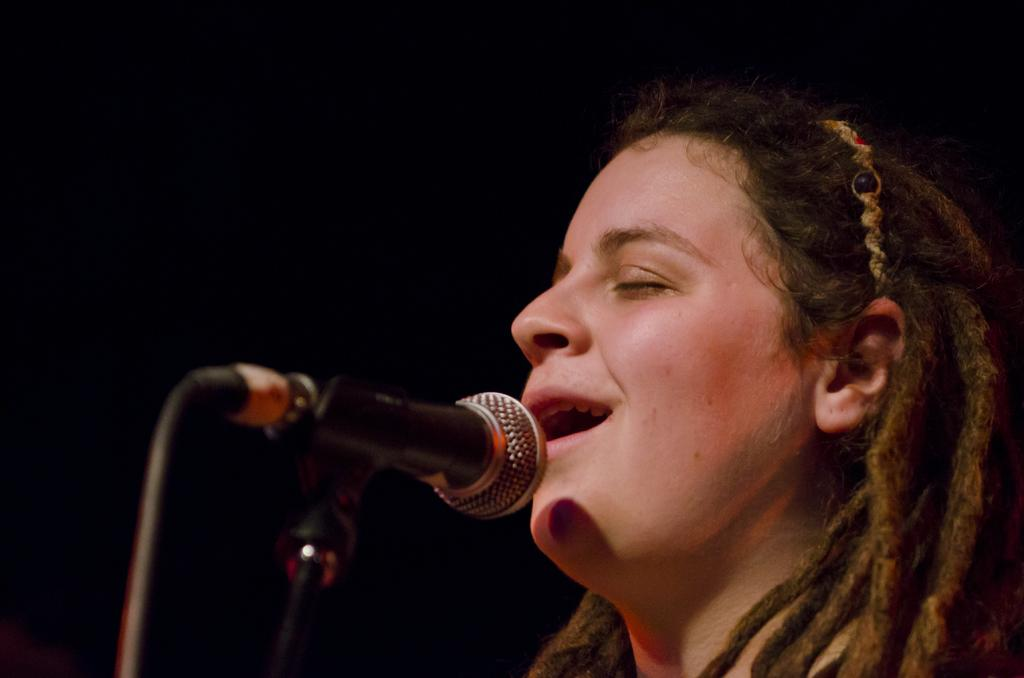What is happening in the image? There is a person in the image who is singing a song. What object is in front of the person? There is a microphone (mike) in front of the person. What type of crime is being committed in the image? There is no crime being committed in the image; it features a person singing with a microphone. How many mice can be seen in the image? There are no mice present in the image. 